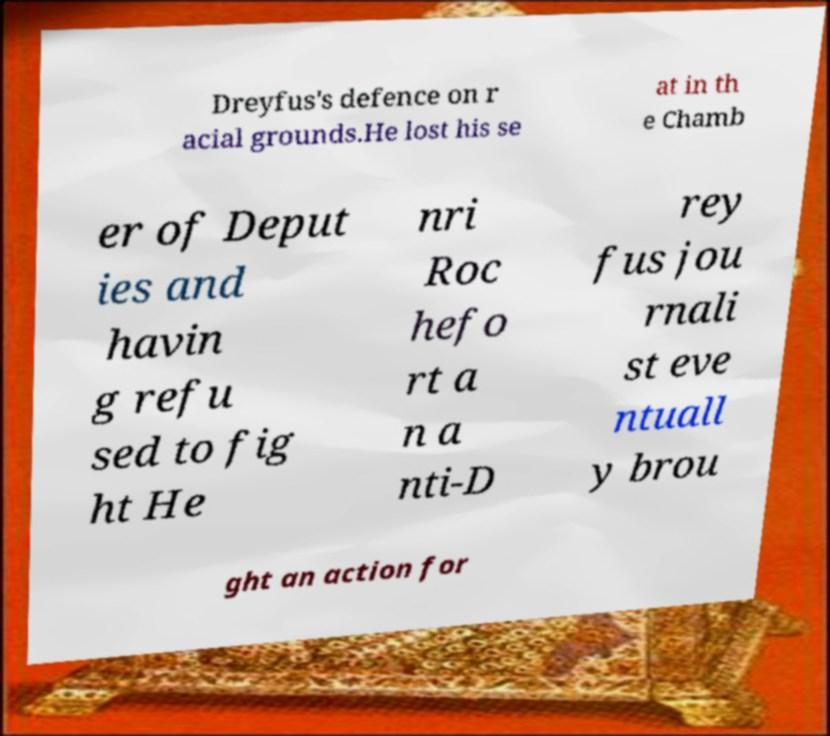Please identify and transcribe the text found in this image. Dreyfus's defence on r acial grounds.He lost his se at in th e Chamb er of Deput ies and havin g refu sed to fig ht He nri Roc hefo rt a n a nti-D rey fus jou rnali st eve ntuall y brou ght an action for 